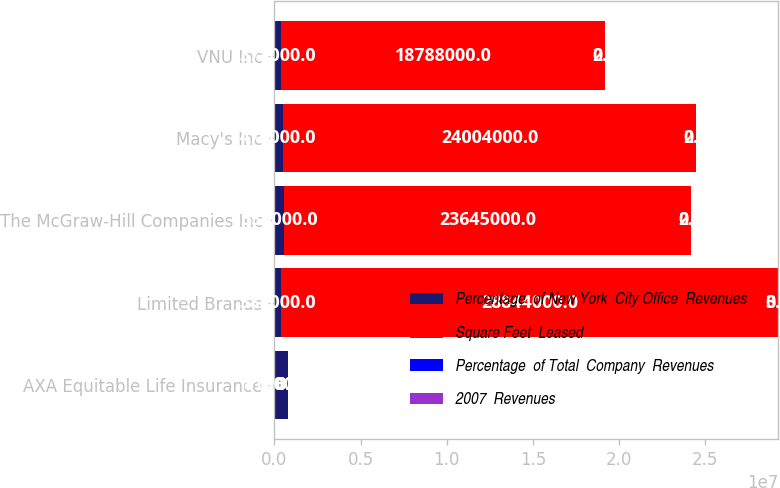<chart> <loc_0><loc_0><loc_500><loc_500><stacked_bar_chart><ecel><fcel>AXA Equitable Life Insurance<fcel>Limited Brands<fcel>The McGraw-Hill Companies Inc<fcel>Macy's Inc<fcel>VNU Inc<nl><fcel>Percentage  of New York  City Office  Revenues<fcel>815000<fcel>382000<fcel>536000<fcel>476000<fcel>372000<nl><fcel>Square Feet  Leased<fcel>3.3<fcel>2.8844e+07<fcel>2.3645e+07<fcel>2.4004e+07<fcel>1.8788e+07<nl><fcel>Percentage  of Total  Company  Revenues<fcel>3.3<fcel>3.1<fcel>2.6<fcel>2.6<fcel>2<nl><fcel>2007  Revenues<fcel>0.9<fcel>0.9<fcel>0.7<fcel>0.7<fcel>0.6<nl></chart> 